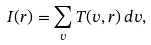Convert formula to latex. <formula><loc_0><loc_0><loc_500><loc_500>I ( { r } ) = { \sum _ { v } T ( v , { r } ) \, d v } ,</formula> 